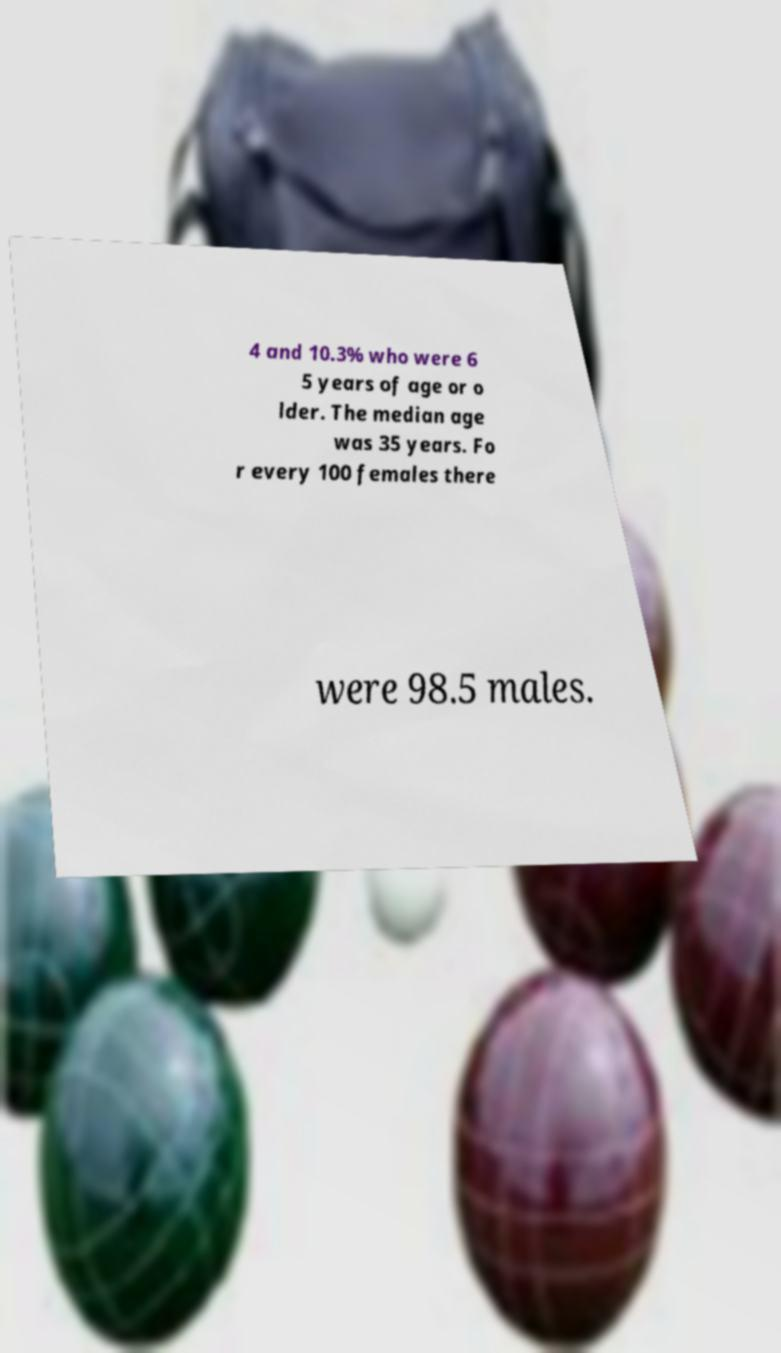Could you extract and type out the text from this image? 4 and 10.3% who were 6 5 years of age or o lder. The median age was 35 years. Fo r every 100 females there were 98.5 males. 